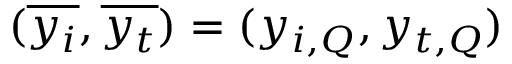Convert formula to latex. <formula><loc_0><loc_0><loc_500><loc_500>( \overline { { y _ { i } } } , \overline { { y _ { t } } } ) = ( y _ { i , Q } , y _ { t , Q } )</formula> 